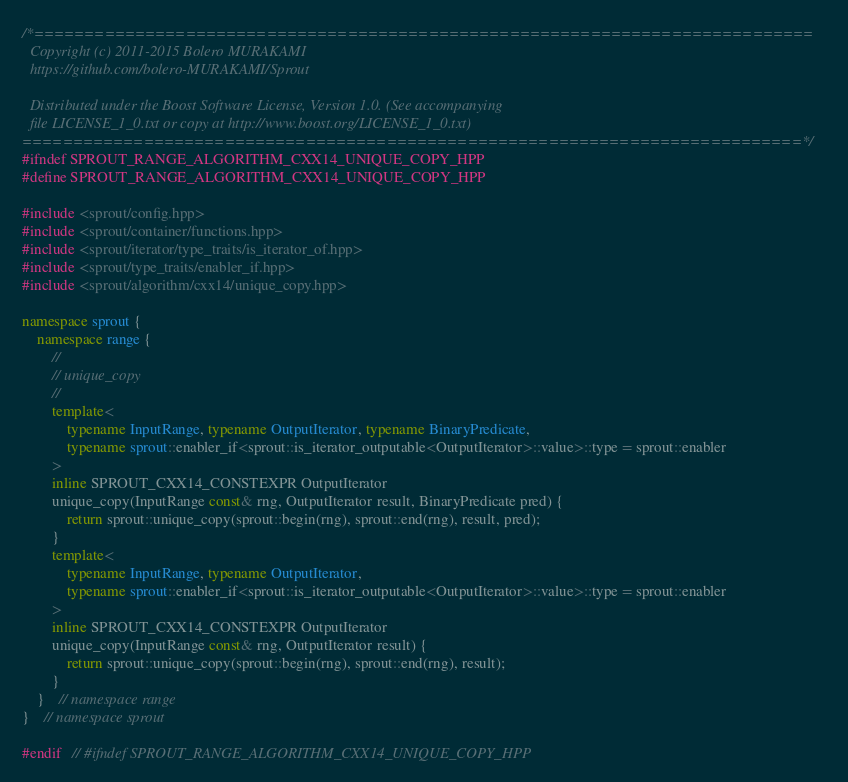<code> <loc_0><loc_0><loc_500><loc_500><_C++_>/*=============================================================================
  Copyright (c) 2011-2015 Bolero MURAKAMI
  https://github.com/bolero-MURAKAMI/Sprout

  Distributed under the Boost Software License, Version 1.0. (See accompanying
  file LICENSE_1_0.txt or copy at http://www.boost.org/LICENSE_1_0.txt)
=============================================================================*/
#ifndef SPROUT_RANGE_ALGORITHM_CXX14_UNIQUE_COPY_HPP
#define SPROUT_RANGE_ALGORITHM_CXX14_UNIQUE_COPY_HPP

#include <sprout/config.hpp>
#include <sprout/container/functions.hpp>
#include <sprout/iterator/type_traits/is_iterator_of.hpp>
#include <sprout/type_traits/enabler_if.hpp>
#include <sprout/algorithm/cxx14/unique_copy.hpp>

namespace sprout {
	namespace range {
		//
		// unique_copy
		//
		template<
			typename InputRange, typename OutputIterator, typename BinaryPredicate,
			typename sprout::enabler_if<sprout::is_iterator_outputable<OutputIterator>::value>::type = sprout::enabler
		>
		inline SPROUT_CXX14_CONSTEXPR OutputIterator
		unique_copy(InputRange const& rng, OutputIterator result, BinaryPredicate pred) {
			return sprout::unique_copy(sprout::begin(rng), sprout::end(rng), result, pred);
		}
		template<
			typename InputRange, typename OutputIterator,
			typename sprout::enabler_if<sprout::is_iterator_outputable<OutputIterator>::value>::type = sprout::enabler
		>
		inline SPROUT_CXX14_CONSTEXPR OutputIterator
		unique_copy(InputRange const& rng, OutputIterator result) {
			return sprout::unique_copy(sprout::begin(rng), sprout::end(rng), result);
		}
	}	// namespace range
}	// namespace sprout

#endif	// #ifndef SPROUT_RANGE_ALGORITHM_CXX14_UNIQUE_COPY_HPP
</code> 